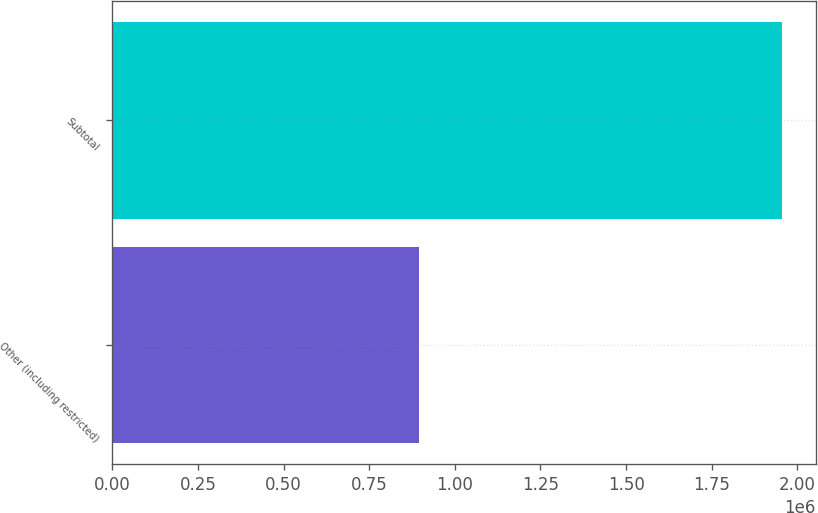Convert chart to OTSL. <chart><loc_0><loc_0><loc_500><loc_500><bar_chart><fcel>Other (including restricted)<fcel>Subtotal<nl><fcel>894770<fcel>1.9565e+06<nl></chart> 